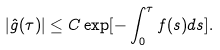<formula> <loc_0><loc_0><loc_500><loc_500>| \hat { g } ( \tau ) | \leq C \exp [ - \int _ { 0 } ^ { \tau } f ( s ) d s ] .</formula> 